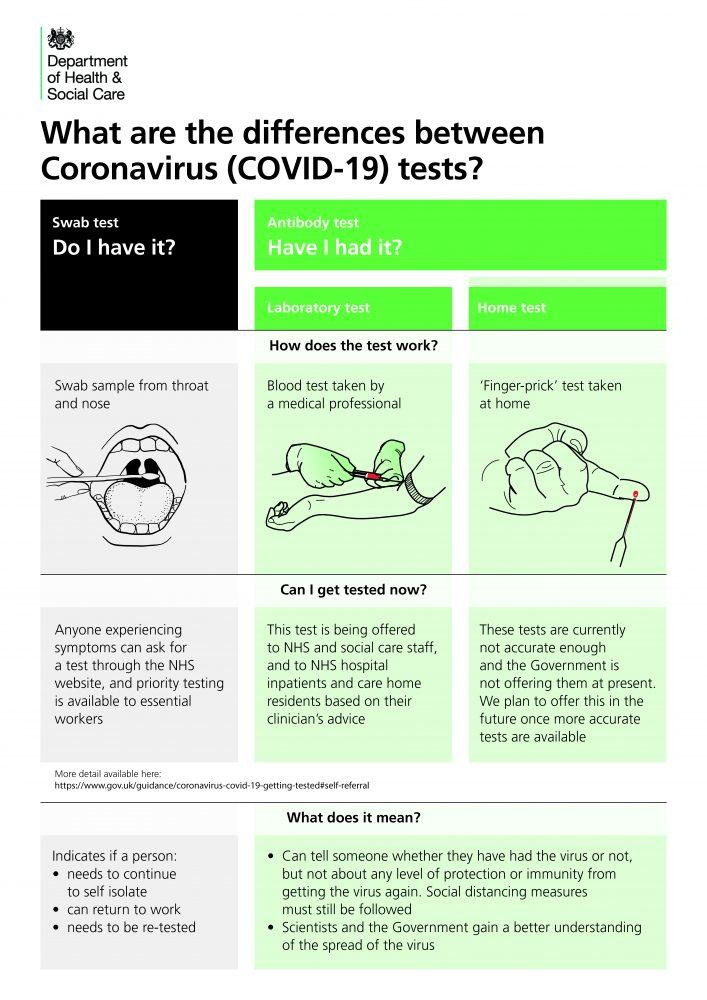Indicate a few pertinent items in this graphic. It is permissible for anyone who is experiencing symptoms to request a swab test. It is inaccurate to rely on home antibody test results for HIV diagnosis as they may produce false positive or false negative results. An antibody test that requires the involvement of a medical professional and is performed in a laboratory setting is known as a laboratory test. There are two ways in which antibody testing can be conducted: laboratory testing and home testing. A swab sample is taken from the throat and nose. 